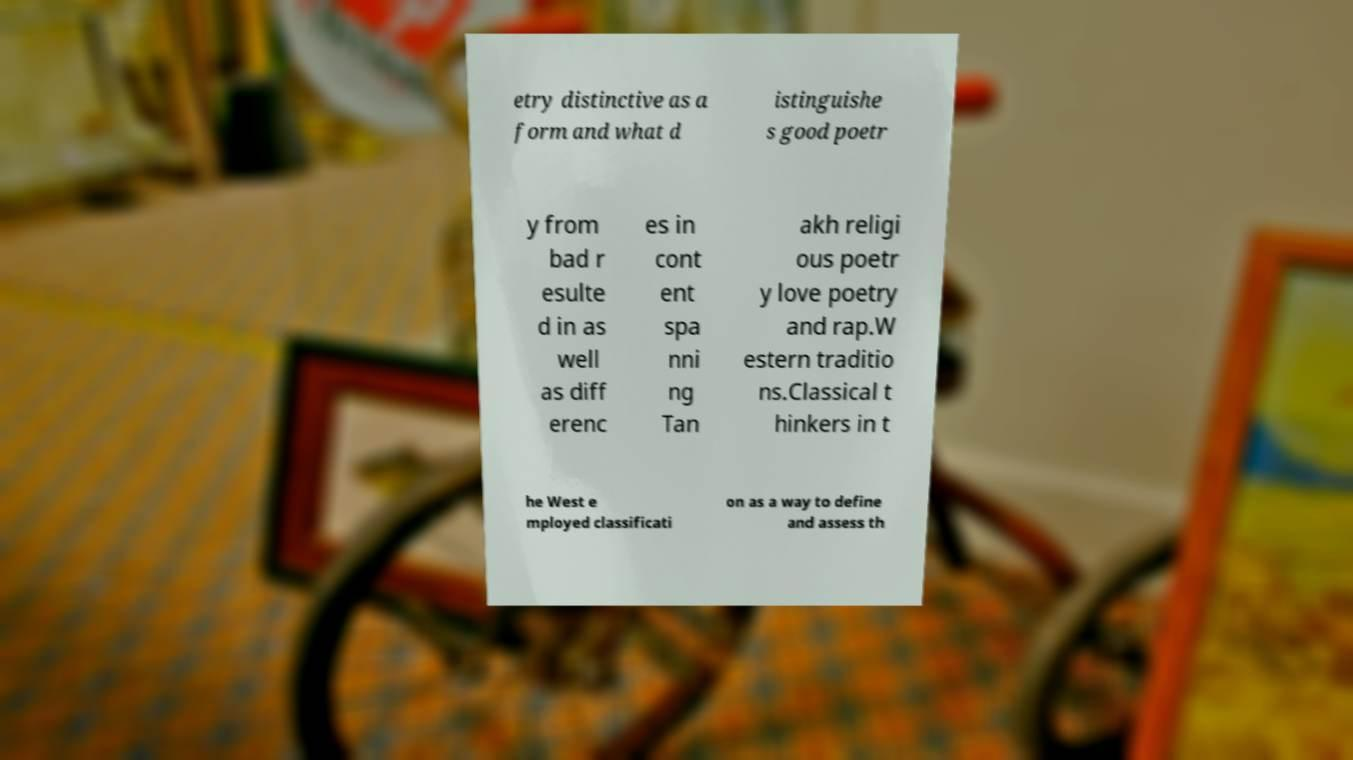There's text embedded in this image that I need extracted. Can you transcribe it verbatim? etry distinctive as a form and what d istinguishe s good poetr y from bad r esulte d in as well as diff erenc es in cont ent spa nni ng Tan akh religi ous poetr y love poetry and rap.W estern traditio ns.Classical t hinkers in t he West e mployed classificati on as a way to define and assess th 